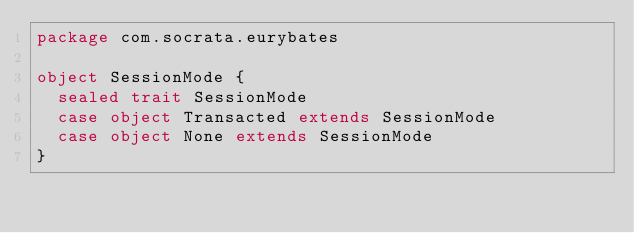<code> <loc_0><loc_0><loc_500><loc_500><_Scala_>package com.socrata.eurybates

object SessionMode {
  sealed trait SessionMode
  case object Transacted extends SessionMode
  case object None extends SessionMode
}
</code> 